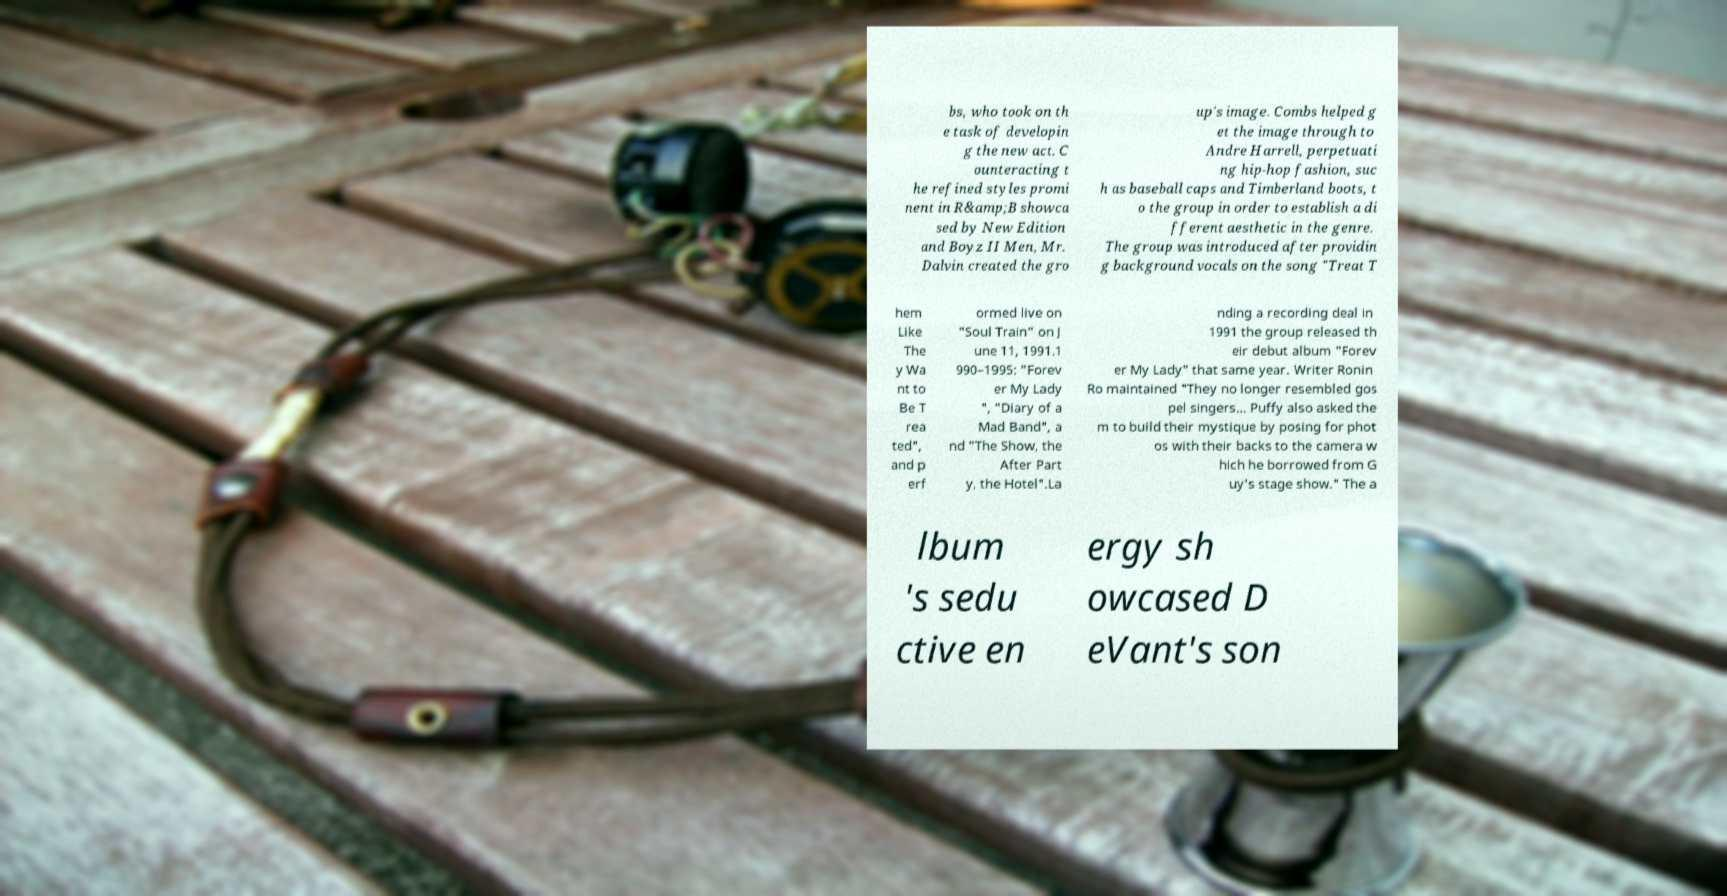Can you accurately transcribe the text from the provided image for me? bs, who took on th e task of developin g the new act. C ounteracting t he refined styles promi nent in R&amp;B showca sed by New Edition and Boyz II Men, Mr. Dalvin created the gro up's image. Combs helped g et the image through to Andre Harrell, perpetuati ng hip-hop fashion, suc h as baseball caps and Timberland boots, t o the group in order to establish a di fferent aesthetic in the genre. The group was introduced after providin g background vocals on the song "Treat T hem Like The y Wa nt to Be T rea ted", and p erf ormed live on "Soul Train" on J une 11, 1991.1 990–1995: "Forev er My Lady ", "Diary of a Mad Band", a nd "The Show, the After Part y, the Hotel".La nding a recording deal in 1991 the group released th eir debut album "Forev er My Lady" that same year. Writer Ronin Ro maintained "They no longer resembled gos pel singers… Puffy also asked the m to build their mystique by posing for phot os with their backs to the camera w hich he borrowed from G uy's stage show." The a lbum 's sedu ctive en ergy sh owcased D eVant's son 